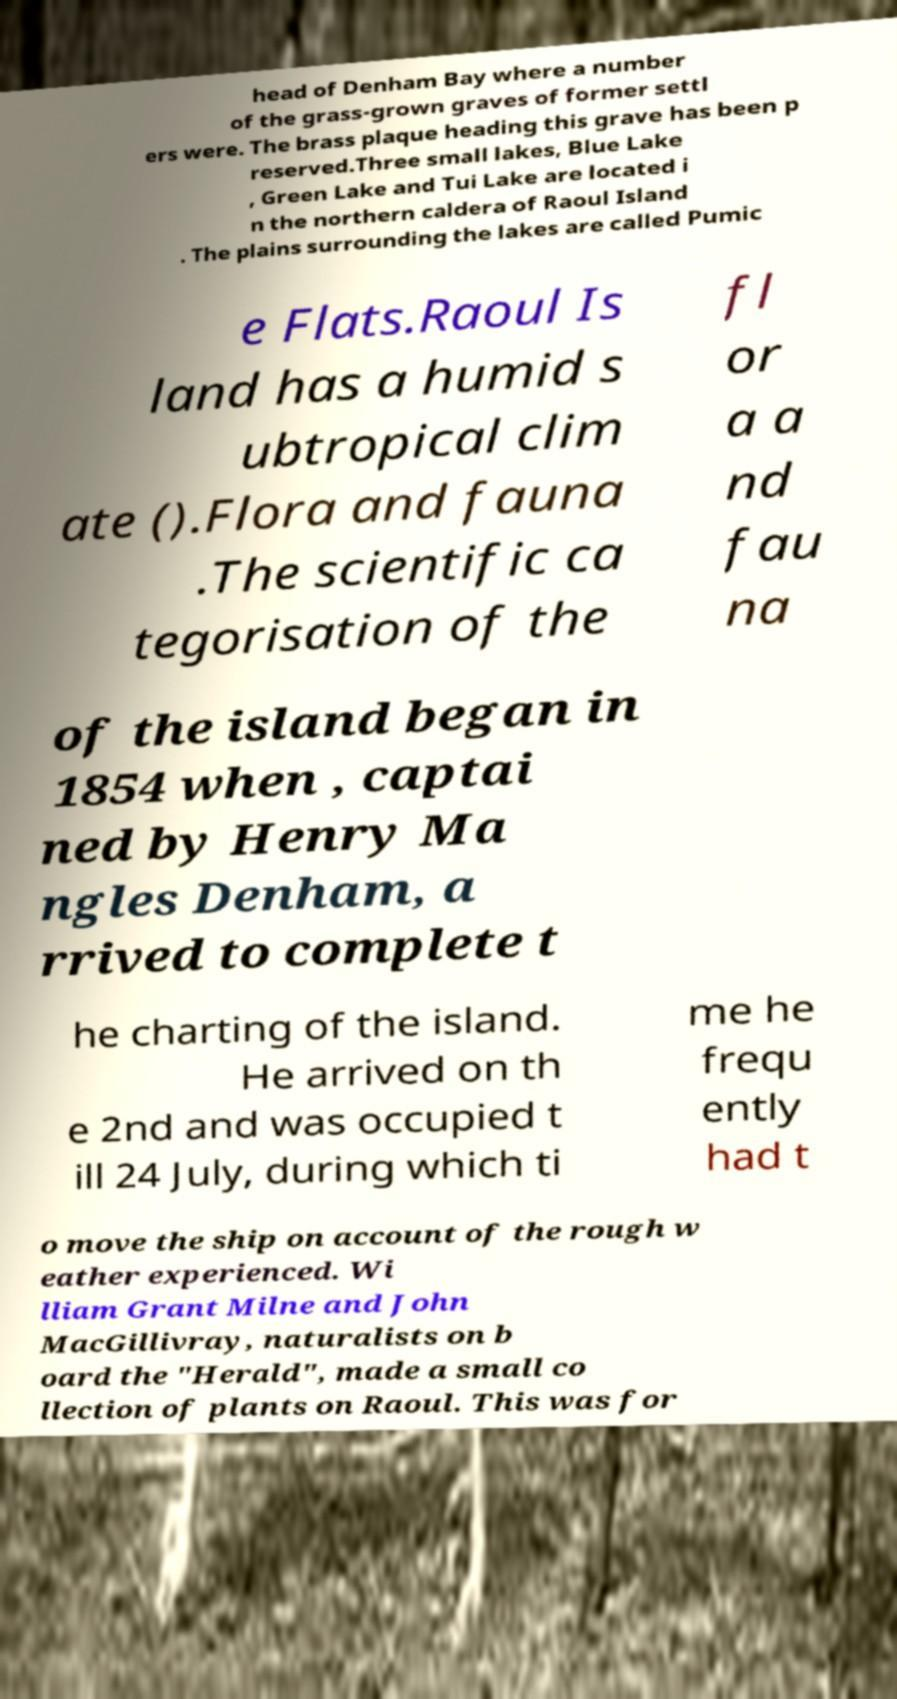For documentation purposes, I need the text within this image transcribed. Could you provide that? head of Denham Bay where a number of the grass-grown graves of former settl ers were. The brass plaque heading this grave has been p reserved.Three small lakes, Blue Lake , Green Lake and Tui Lake are located i n the northern caldera of Raoul Island . The plains surrounding the lakes are called Pumic e Flats.Raoul Is land has a humid s ubtropical clim ate ().Flora and fauna .The scientific ca tegorisation of the fl or a a nd fau na of the island began in 1854 when , captai ned by Henry Ma ngles Denham, a rrived to complete t he charting of the island. He arrived on th e 2nd and was occupied t ill 24 July, during which ti me he frequ ently had t o move the ship on account of the rough w eather experienced. Wi lliam Grant Milne and John MacGillivray, naturalists on b oard the "Herald", made a small co llection of plants on Raoul. This was for 